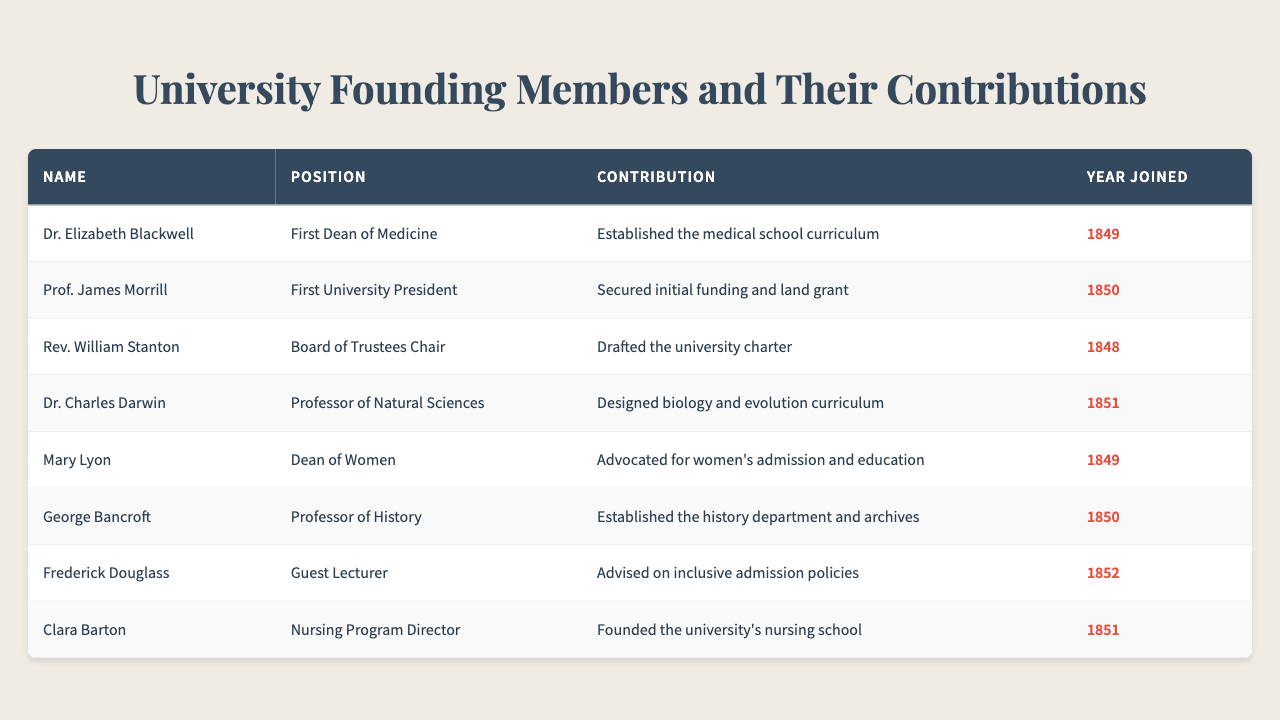What year did Dr. Elizabeth Blackwell join the university? Dr. Elizabeth Blackwell's year of joining is listed in the table under "Year Joined," where it states she joined in 1849.
Answer: 1849 What was Prof. James Morrill's contribution to the university? The table indicates that Prof. James Morrill's contribution was securing initial funding and land grant, listed under “Contribution.”
Answer: Secured initial funding and land grant How many founding members joined the university in 1850? By examining the "Year Joined" column, we can see that there are two members who joined in 1850: Prof. James Morrill and George Bancroft.
Answer: 2 Which founding member advocated for women's admission and education? The table specifies that Mary Lyon was the founding member who advocated for women's admission and education, as mentioned in her contribution.
Answer: Mary Lyon Was Dr. Charles Darwin involved in establishing the nursing program? Referring to the table, Dr. Charles Darwin is not mentioned in relation to the nursing program; Clara Barton is noted for founding the nursing school.
Answer: No What is the contribution of the founding member who joined in 1852? The founding member who joined in 1852 is Frederick Douglass, and his contribution, as per the table, was advising on inclusive admission policies.
Answer: Advised on inclusive admission policies List all the positions held by members who joined the university before 1850. The table shows three members joined before 1850: Rev. William Stanton (Board of Trustees Chair), Dr. Elizabeth Blackwell (First Dean of Medicine), and Mary Lyon (Dean of Women). Their positions are listed next to their names.
Answer: Board of Trustees Chair, First Dean of Medicine, Dean of Women Which founding member was responsible for drafting the university charter? The table indicates that Rev. William Stanton was responsible for drafting the university charter, as noted in the "Contribution" column.
Answer: Rev. William Stanton How many total contributions related to education can be found in the table? There are three contributions specifically about education: Dr. Elizabeth Blackwell (established the medical school curriculum), Mary Lyon (advocated for women's admission and education), and Clara Barton (founded the nursing school). Therefore, the total is three.
Answer: 3 What relationship can be drawn between the year joined and the contributions of the members in 1851? In 1851, two members joined: Dr. Charles Darwin, who designed the biology and evolution curriculum, and Clara Barton, who founded the nursing school. This shows a strong focus on developing educational programs in that year.
Answer: Strong focus on educational programs 